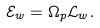<formula> <loc_0><loc_0><loc_500><loc_500>\mathcal { E } _ { w } = \Omega _ { p } \mathcal { L } _ { w } .</formula> 